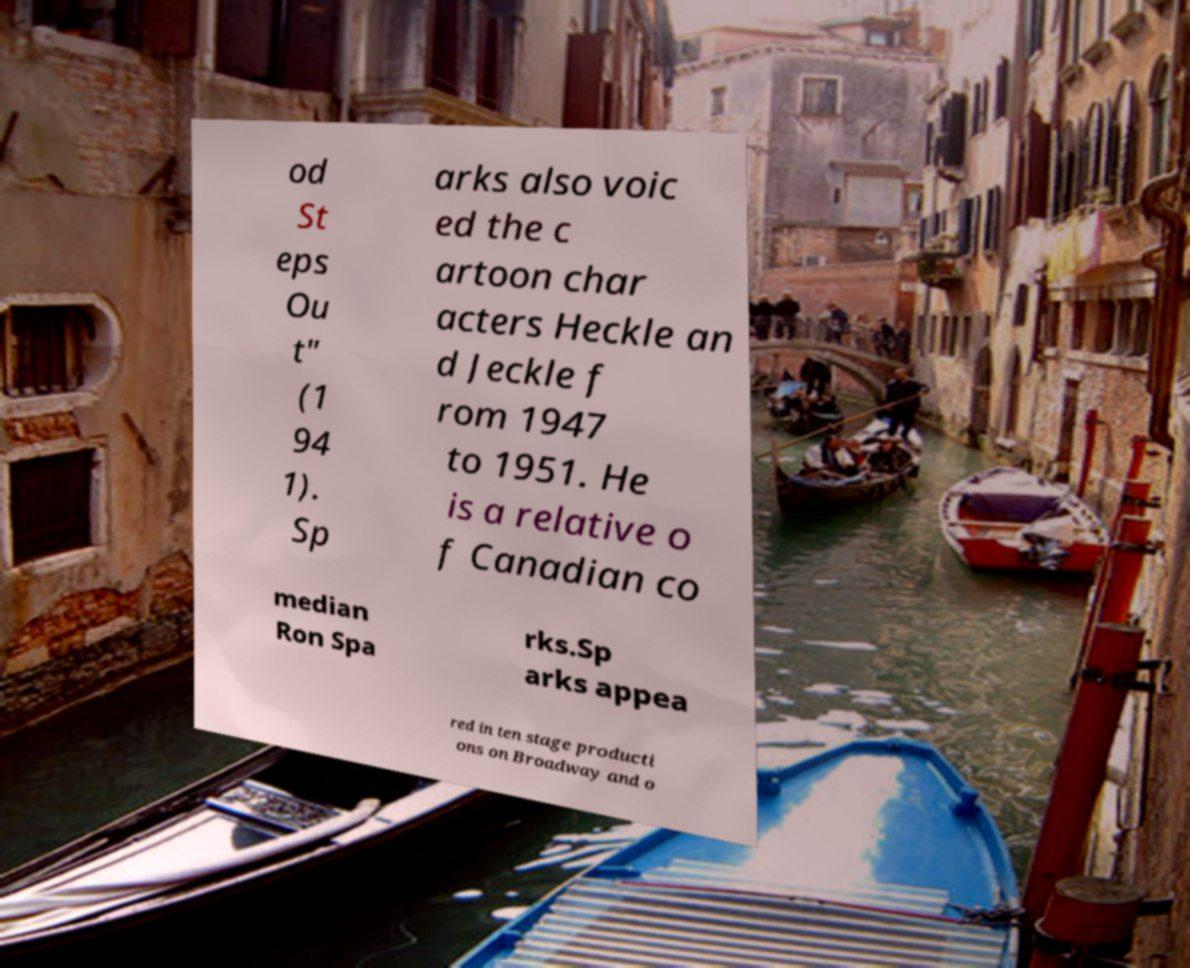Could you extract and type out the text from this image? od St eps Ou t" (1 94 1). Sp arks also voic ed the c artoon char acters Heckle an d Jeckle f rom 1947 to 1951. He is a relative o f Canadian co median Ron Spa rks.Sp arks appea red in ten stage producti ons on Broadway and o 